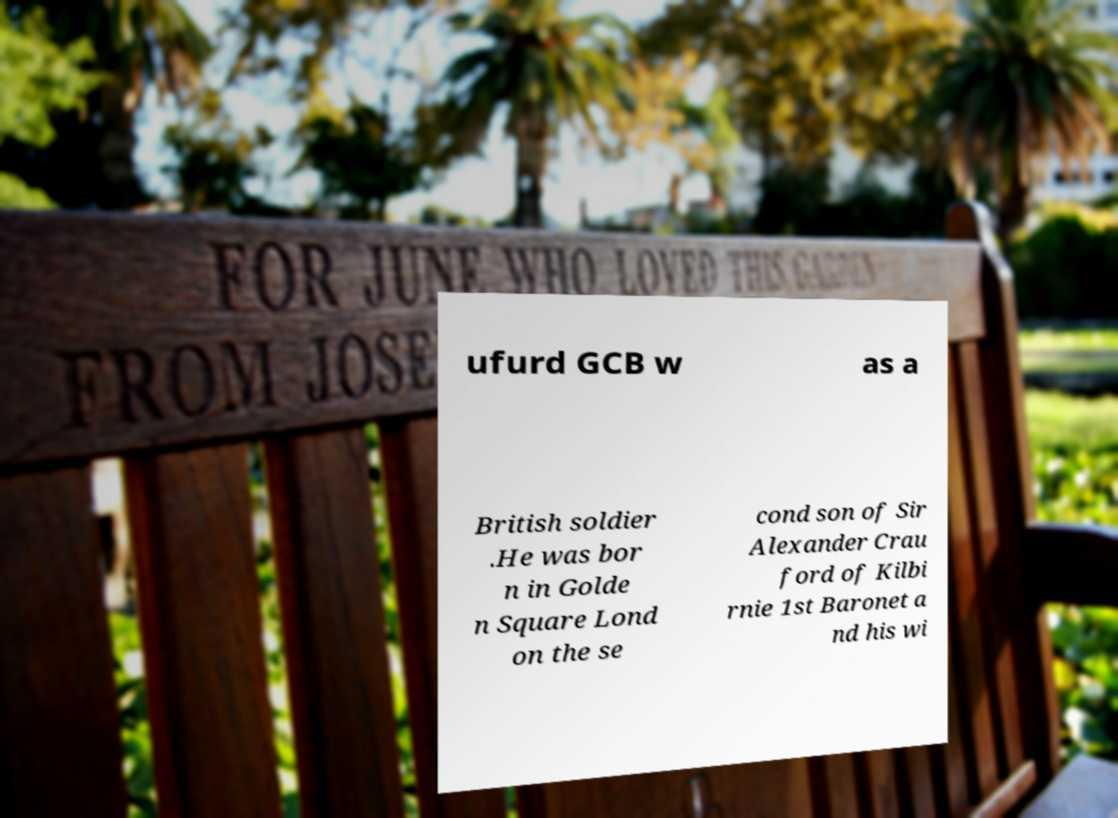I need the written content from this picture converted into text. Can you do that? ufurd GCB w as a British soldier .He was bor n in Golde n Square Lond on the se cond son of Sir Alexander Crau ford of Kilbi rnie 1st Baronet a nd his wi 